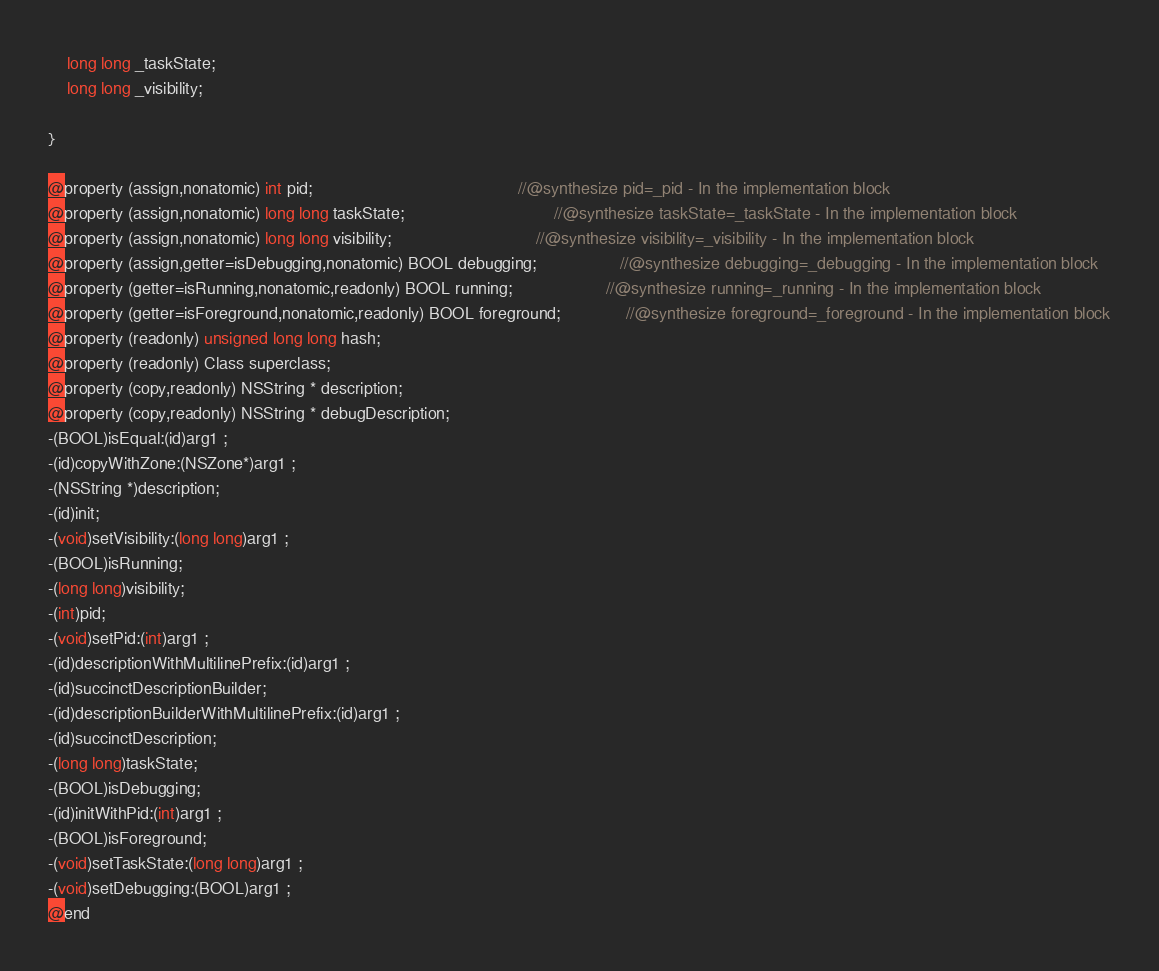Convert code to text. <code><loc_0><loc_0><loc_500><loc_500><_C_>	long long _taskState;
	long long _visibility;

}

@property (assign,nonatomic) int pid;                                            //@synthesize pid=_pid - In the implementation block
@property (assign,nonatomic) long long taskState;                                //@synthesize taskState=_taskState - In the implementation block
@property (assign,nonatomic) long long visibility;                               //@synthesize visibility=_visibility - In the implementation block
@property (assign,getter=isDebugging,nonatomic) BOOL debugging;                  //@synthesize debugging=_debugging - In the implementation block
@property (getter=isRunning,nonatomic,readonly) BOOL running;                    //@synthesize running=_running - In the implementation block
@property (getter=isForeground,nonatomic,readonly) BOOL foreground;              //@synthesize foreground=_foreground - In the implementation block
@property (readonly) unsigned long long hash; 
@property (readonly) Class superclass; 
@property (copy,readonly) NSString * description; 
@property (copy,readonly) NSString * debugDescription; 
-(BOOL)isEqual:(id)arg1 ;
-(id)copyWithZone:(NSZone*)arg1 ;
-(NSString *)description;
-(id)init;
-(void)setVisibility:(long long)arg1 ;
-(BOOL)isRunning;
-(long long)visibility;
-(int)pid;
-(void)setPid:(int)arg1 ;
-(id)descriptionWithMultilinePrefix:(id)arg1 ;
-(id)succinctDescriptionBuilder;
-(id)descriptionBuilderWithMultilinePrefix:(id)arg1 ;
-(id)succinctDescription;
-(long long)taskState;
-(BOOL)isDebugging;
-(id)initWithPid:(int)arg1 ;
-(BOOL)isForeground;
-(void)setTaskState:(long long)arg1 ;
-(void)setDebugging:(BOOL)arg1 ;
@end

</code> 